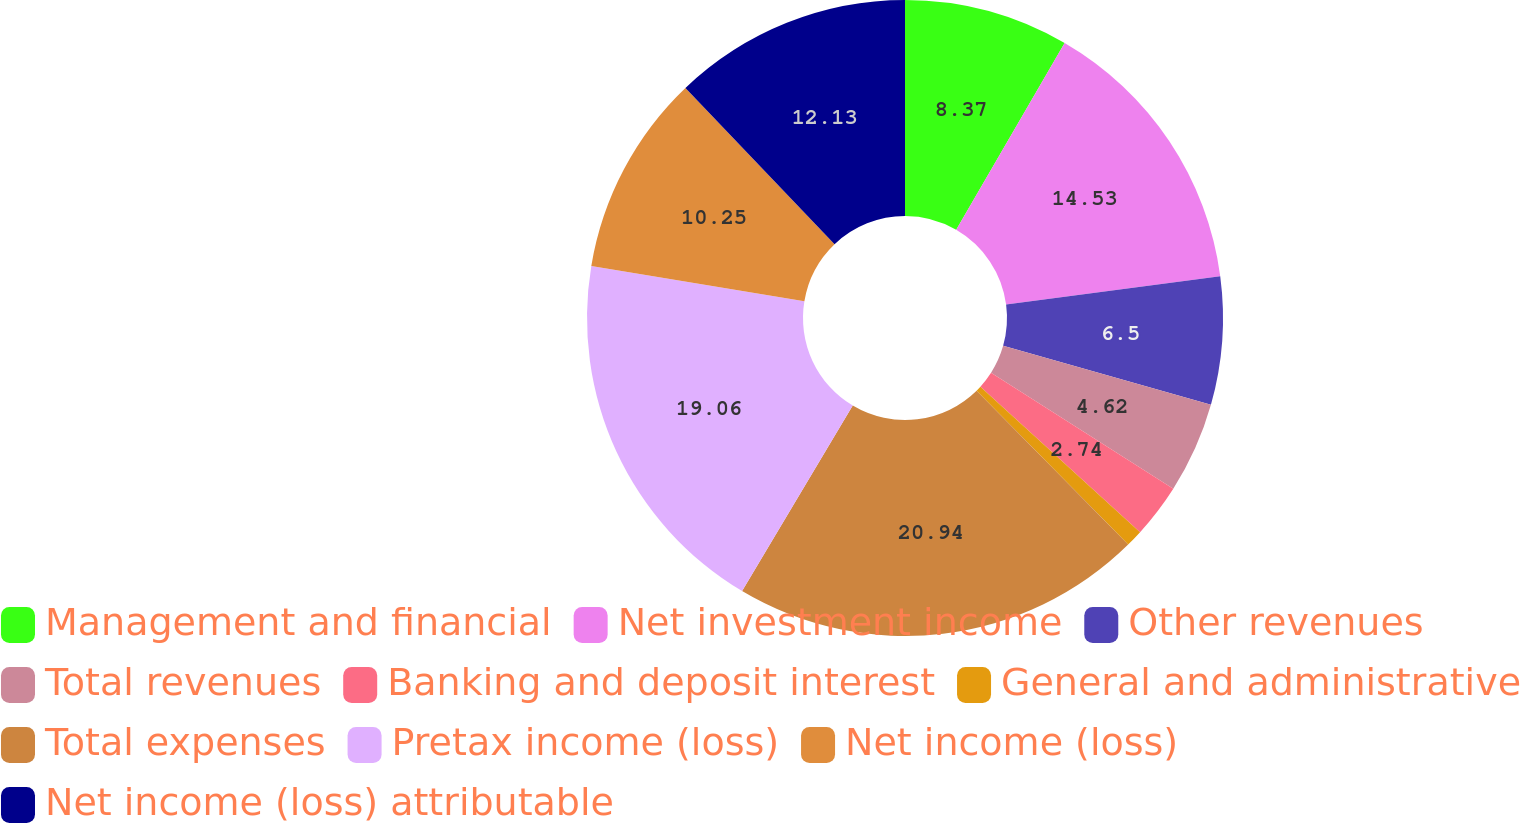<chart> <loc_0><loc_0><loc_500><loc_500><pie_chart><fcel>Management and financial<fcel>Net investment income<fcel>Other revenues<fcel>Total revenues<fcel>Banking and deposit interest<fcel>General and administrative<fcel>Total expenses<fcel>Pretax income (loss)<fcel>Net income (loss)<fcel>Net income (loss) attributable<nl><fcel>8.37%<fcel>14.53%<fcel>6.5%<fcel>4.62%<fcel>2.74%<fcel>0.86%<fcel>20.94%<fcel>19.06%<fcel>10.25%<fcel>12.13%<nl></chart> 